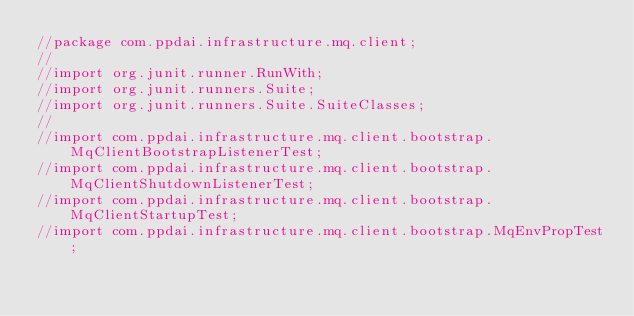Convert code to text. <code><loc_0><loc_0><loc_500><loc_500><_Java_>//package com.ppdai.infrastructure.mq.client;
//
//import org.junit.runner.RunWith;
//import org.junit.runners.Suite;
//import org.junit.runners.Suite.SuiteClasses;
//
//import com.ppdai.infrastructure.mq.client.bootstrap.MqClientBootstrapListenerTest;
//import com.ppdai.infrastructure.mq.client.bootstrap.MqClientShutdownListenerTest;
//import com.ppdai.infrastructure.mq.client.bootstrap.MqClientStartupTest;
//import com.ppdai.infrastructure.mq.client.bootstrap.MqEnvPropTest;</code> 